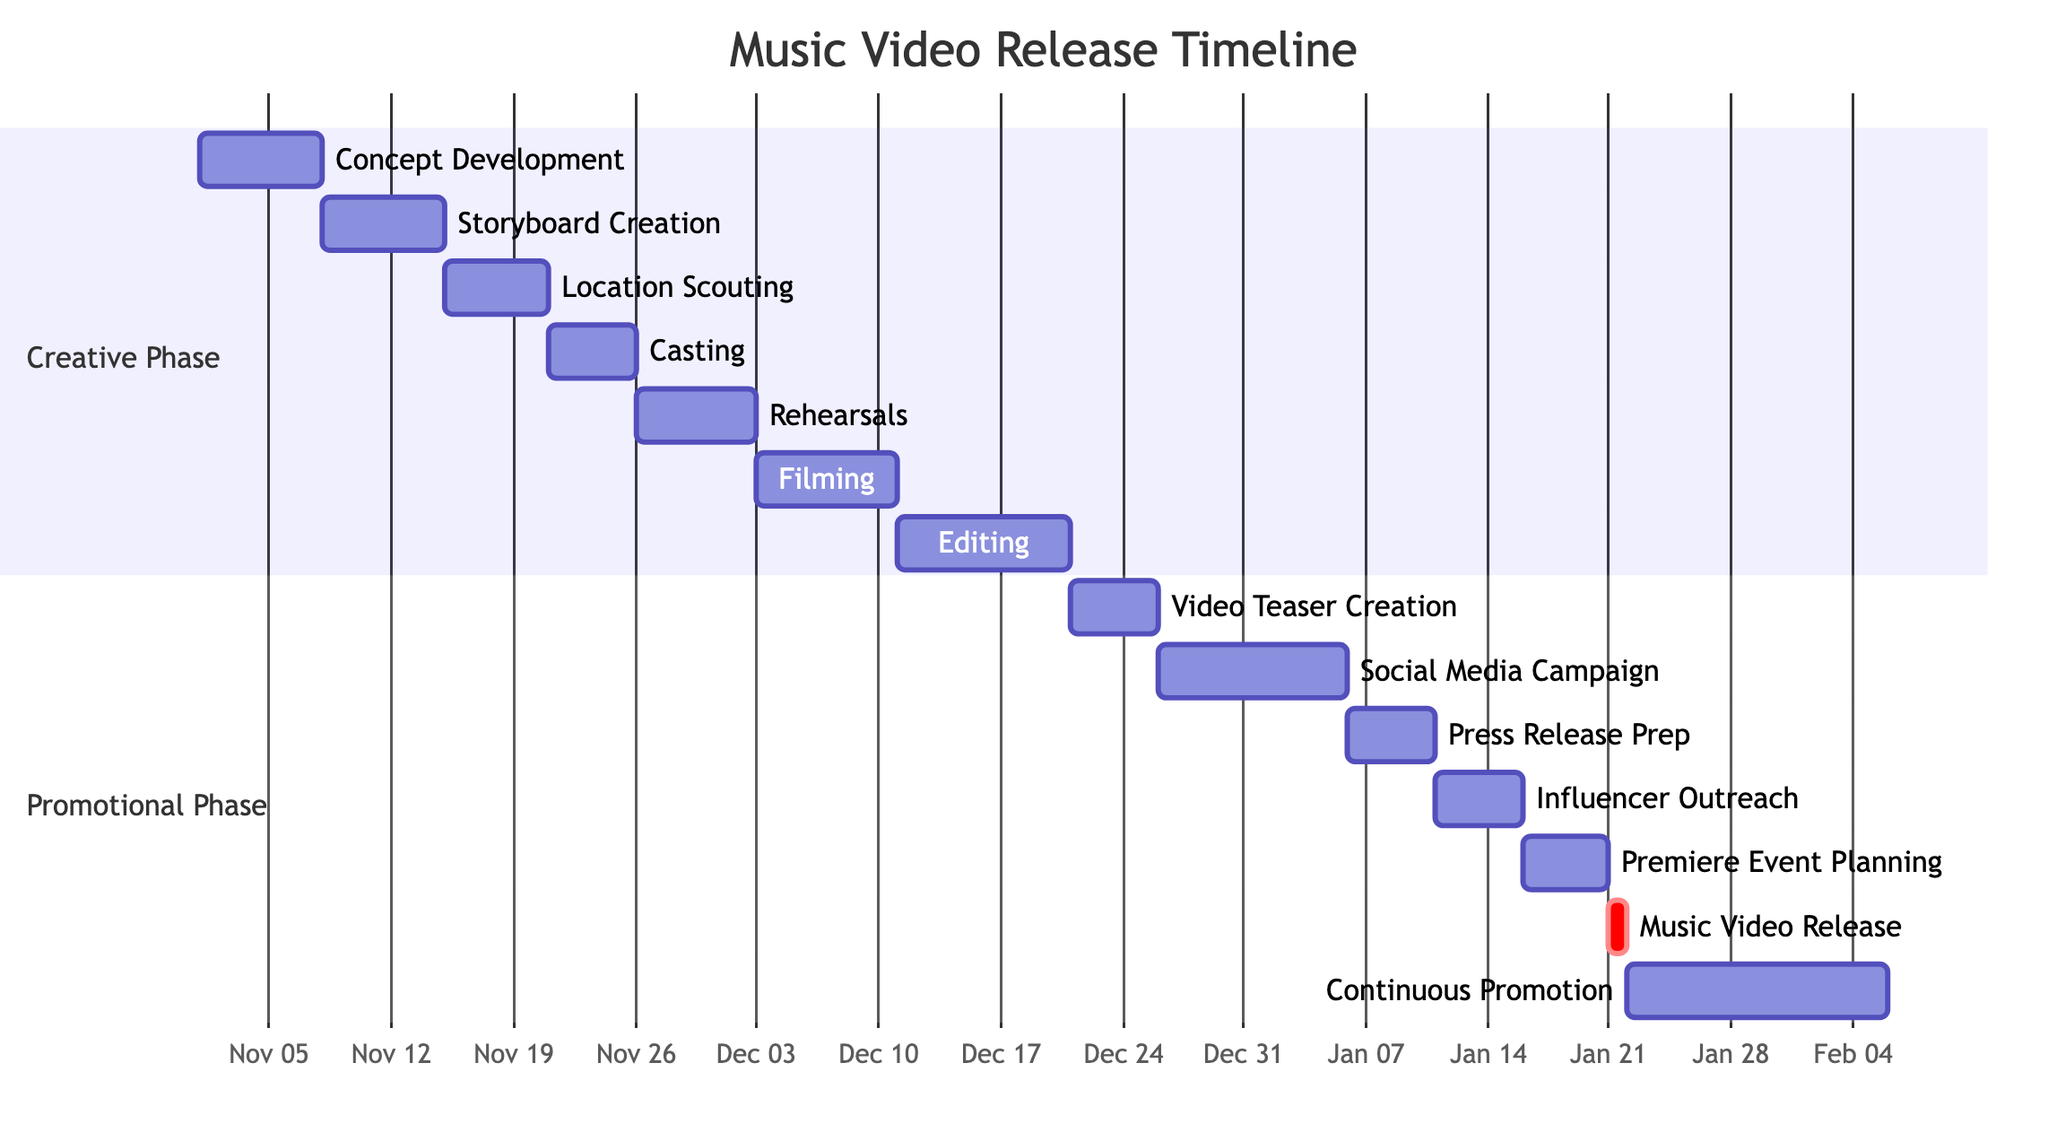What is the duration of the Concept Development task? The Concept Development task starts on November 1, 2023, and ends on November 7, 2023. Counting these days gives a duration of 7 days.
Answer: 7 days How many tasks are in the Creative Phase? The Creative Phase includes Concept Development, Storyboard Creation, Location Scouting, Casting, Rehearsals, Filming, and Editing, totaling 7 tasks.
Answer: 7 tasks What is the end date of the Music Video Release? The Music Video Release is scheduled for January 21, 2024. This date is indicated directly in the task entry of the diagram.
Answer: January 21, 2024 Which task overlaps with both the Editing and Video Teaser Creation tasks? The Editing task runs from December 11, 2023, to December 20, 2023, while the Video Teaser Creation starts on December 21, 2023. Hence, no task overlaps, but since there's a gap, the question intended to signify that there is a seamless transition.
Answer: None What is the total span of the Promotional Phase? The Promotional Phase starts on December 21, 2023, with the Video Teaser Creation, and ends on February 5, 2024, with Continuous Promotion. Calculating the days between these two dates gives a total duration of 46 days.
Answer: 46 days What is the relation between the Rehearsals and Filming tasks in terms of scheduling? The Rehearsals task finishes on December 2, 2023, and the Filming task begins on December 3, 2023, indicating that Rehearsals directly precede Filming without any gaps in scheduling.
Answer: Directly precede In what period does the Social Media Campaign take place? The Social Media Campaign initiates on December 26, 2023, and continues until January 5, 2024. By referring to the diagram, we can see its start and end dates clearly.
Answer: December 26, 2023 to January 5, 2024 How long does the Continuous Promotion last after the Music Video Release? Continuous Promotion starts on January 22, 2024, and lasts until February 5, 2024. This indicates a duration of 15 days after the Music Video Release.
Answer: 15 days What is the first task that occurs in the Creative Phase? The first task in the Creative Phase is Concept Development, which begins on November 1, 2023. The diagram clearly represents this sequence.
Answer: Concept Development 